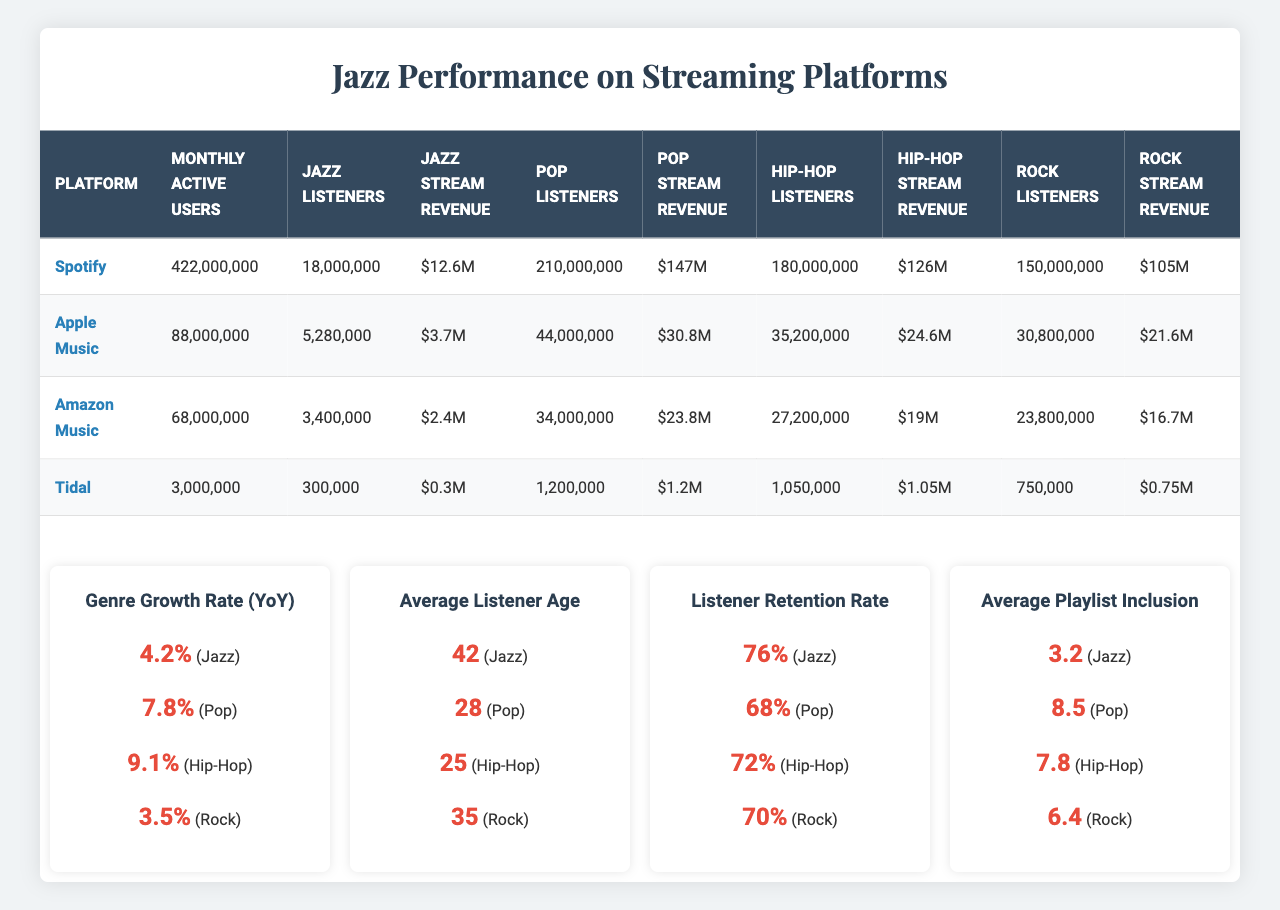What's the total number of Jazz listeners across all platforms? To find the total Jazz listeners, sum up the Jazz Listeners from each platform: 18,000,000 (Spotify) + 5,280,000 (Apple Music) + 3,400,000 (Amazon Music) + 300,000 (Tidal) = 26,980,000
Answer: 26,980,000 Which platform has the highest Jazz stream revenue? By comparing Jazz Stream Revenue for each platform, Spotify has $12.6M, Apple Music has $3.7M, Amazon Music has $2.4M, and Tidal has $0.3M. The highest revenue is from Spotify.
Answer: Spotify What is the average age of Jazz listeners? The average age of Jazz listeners is directly given in the data, which is 42 years.
Answer: 42 Is the YoY growth rate for Jazz higher than that of Rock? The YoY growth rate for Jazz is 4.2%, while Rock's is 3.5%. Since 4.2% is greater than 3.5%, the answer is yes.
Answer: Yes What is the difference in the number of Jazz listeners between Spotify and Apple Music? The number of Jazz listeners on Spotify is 18,000,000 and on Apple Music is 5,280,000. The difference is 18,000,000 - 5,280,000 = 12,720,000.
Answer: 12,720,000 Which genre has the highest listener retention rate and how does Jazz compare? The listener retention rates are 76% (Jazz), 68% (Pop), 72% (Hip-Hop), and 70% (Rock). The highest is Jazz at 76%, which is above all other genres.
Answer: Jazz If we combine the total stream revenue for Pop across all platforms, what is the amount? Summing the Pop Stream Revenue from each platform gives us $147M (Spotify) + $30.8M (Apple Music) + $23.8M (Amazon Music) + $1.2M (Tidal) = $202.8M.
Answer: $202.8M On which streaming platform does Jazz have the lowest listener count? Comparing Jazz listeners across platforms, Tidal has the lowest with 300,000 listeners, while others have significantly more: Spotify (18M), Apple Music (5.28M), Amazon Music (3.4M).
Answer: Tidal Calculate the total Rock stream revenue across all platforms. The Rock Stream Revenue per platform is: $105M (Spotify) + $21.6M (Apple Music) + $16.7M (Amazon Music) + $0.75M (Tidal) = $144.05M total for Rock.
Answer: $144.05M Is the average playlist inclusion for Jazz larger than that for Hip-Hop? The average playlist inclusion for Jazz is 3.2, while for Hip-Hop it is 7.8. Since 3.2 is less than 7.8, the answer is no.
Answer: No 